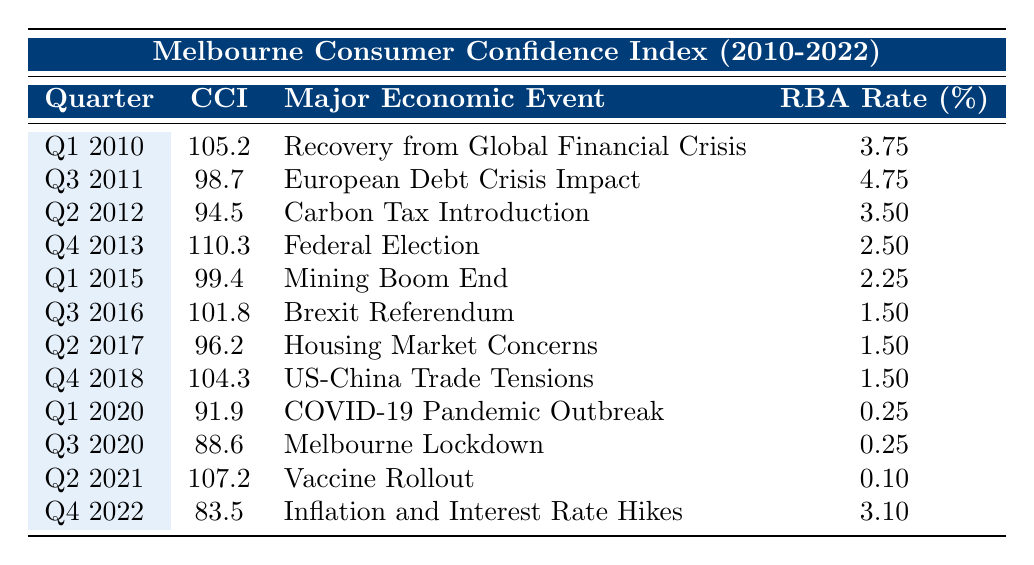What was the Consumer Confidence Index in Q4 2013? The table shows that in Q4 2013, the Consumer Confidence Index is listed as 110.3.
Answer: 110.3 Which major economic event occurred in Q1 2020? The table indicates that the major economic event in Q1 2020 was the COVID-19 Pandemic Outbreak.
Answer: COVID-19 Pandemic Outbreak What is the RBA Cash Rate during Q3 2020? The RBA Cash Rate during Q3 2020, according to the table, is 0.25%.
Answer: 0.25% Calculate the difference in the Consumer Confidence Index between Q2 2012 and Q4 2013. The Consumer Confidence Index in Q4 2013 is 110.3, and in Q2 2012 it is 94.5. The difference is 110.3 - 94.5 = 15.8.
Answer: 15.8 What was the average Consumer Confidence Index from Q1 2010 to Q4 2022? To find the average, first sum the Consumer Confidence Index values: 105.2 + 98.7 + 94.5 + 110.3 + 99.4 + 101.8 + 96.2 + 104.3 + 91.9 + 88.6 + 107.2 + 83.5 = 1,196. The total number of quarters is 12. Therefore, the average is 1,196 / 12 = 99.67.
Answer: 99.67 Was the Consumer Confidence Index higher in Q1 2015 or Q4 2018? In Q1 2015, the index was 99.4, and in Q4 2018, it was 104.3. Thus, Q4 2018 had a higher index.
Answer: Yes How many quarters had a Consumer Confidence Index below 100? Looking through the table, the quarters with an index below 100 are Q3 2011 (98.7), Q2 2012 (94.5), Q1 2015 (99.4), Q2 2017 (96.2), Q1 2020 (91.9), and Q3 2020 (88.6). This makes a total of 6 quarters.
Answer: 6 What percentage of the Consumer Confidence Index in Q2 2021 was the highest compared to Q4 2022? The Consumer Confidence Index in Q2 2021 is 107.2, and in Q4 2022 is 83.5. To find the percentage, calculate (107.2 / 83.5) × 100 = 128.5%.
Answer: 128.5% Which quarter had the lowest RBA Cash Rate and what was it? The table shows that the lowest RBA Cash Rate was in Q2 2021 at 0.10%.
Answer: 0.10% 